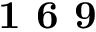Convert formula to latex. <formula><loc_0><loc_0><loc_500><loc_500>1 6 9</formula> 